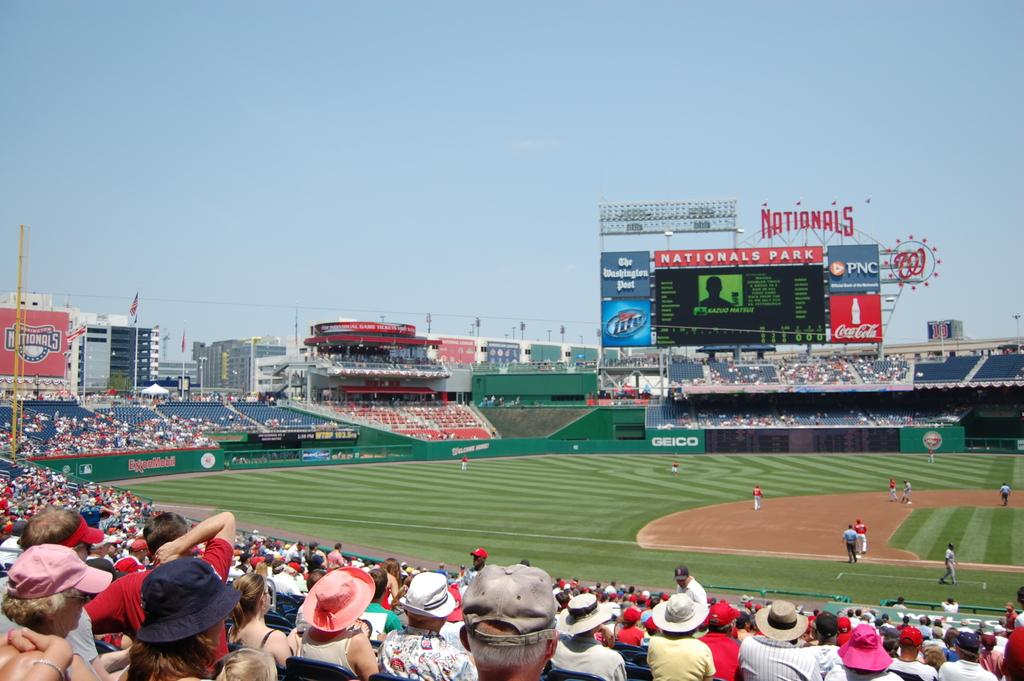<image>
Summarize the visual content of the image. A crowd on Nationals Park sponsored by Miller LIte, PNC and Coca Cola. 